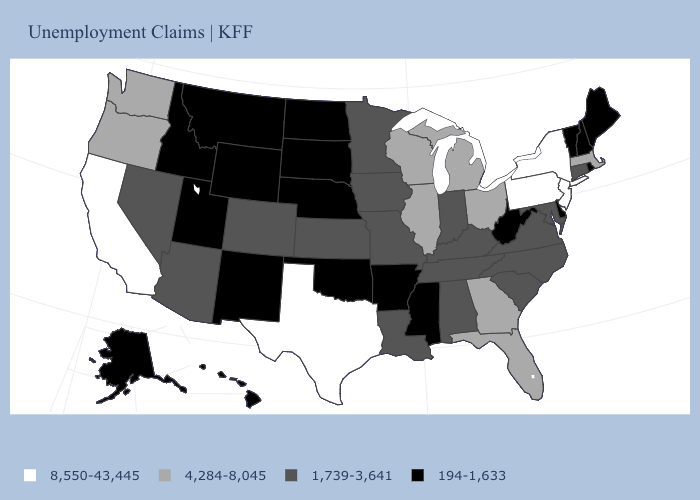What is the value of Wyoming?
Write a very short answer. 194-1,633. Name the states that have a value in the range 8,550-43,445?
Concise answer only. California, New Jersey, New York, Pennsylvania, Texas. Does the first symbol in the legend represent the smallest category?
Be succinct. No. Does New York have a higher value than South Carolina?
Short answer required. Yes. What is the value of Montana?
Keep it brief. 194-1,633. Name the states that have a value in the range 4,284-8,045?
Answer briefly. Florida, Georgia, Illinois, Massachusetts, Michigan, Ohio, Oregon, Washington, Wisconsin. Does Idaho have a lower value than Vermont?
Quick response, please. No. What is the value of Rhode Island?
Give a very brief answer. 194-1,633. Name the states that have a value in the range 4,284-8,045?
Concise answer only. Florida, Georgia, Illinois, Massachusetts, Michigan, Ohio, Oregon, Washington, Wisconsin. Which states have the lowest value in the Northeast?
Answer briefly. Maine, New Hampshire, Rhode Island, Vermont. Name the states that have a value in the range 4,284-8,045?
Give a very brief answer. Florida, Georgia, Illinois, Massachusetts, Michigan, Ohio, Oregon, Washington, Wisconsin. Which states have the highest value in the USA?
Be succinct. California, New Jersey, New York, Pennsylvania, Texas. Does Idaho have the lowest value in the USA?
Keep it brief. Yes. Name the states that have a value in the range 194-1,633?
Quick response, please. Alaska, Arkansas, Delaware, Hawaii, Idaho, Maine, Mississippi, Montana, Nebraska, New Hampshire, New Mexico, North Dakota, Oklahoma, Rhode Island, South Dakota, Utah, Vermont, West Virginia, Wyoming. 